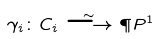Convert formula to latex. <formula><loc_0><loc_0><loc_500><loc_500>\gamma _ { i } \colon C _ { i } \stackrel { \sim } { \longrightarrow } \P P ^ { 1 }</formula> 